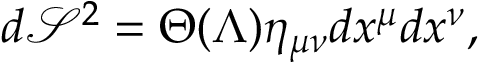Convert formula to latex. <formula><loc_0><loc_0><loc_500><loc_500>d \mathcal { S } ^ { 2 } = \Theta ( \Lambda ) \eta _ { \mu \nu } d x ^ { \mu } d x ^ { \nu } ,</formula> 